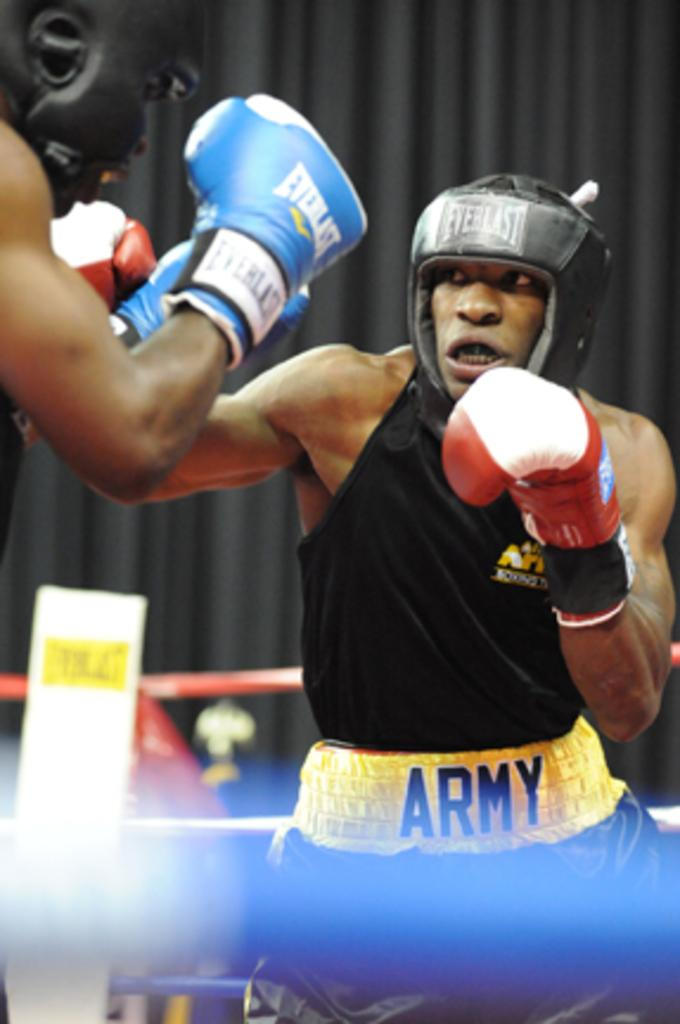How many people are in the image? There are two people in the image. What are the two people doing? The two people are boxing. What can be seen around the boxing area? There are ropes in the image. What color is the cloth in the background of the image? The cloth in the background of the image is black. What type of test is being conducted in the image? There is no test being conducted in the image; it features two people boxing. What does the person in the image regret? There is no indication of regret in the image, as it focuses on the boxing match between the two people. 